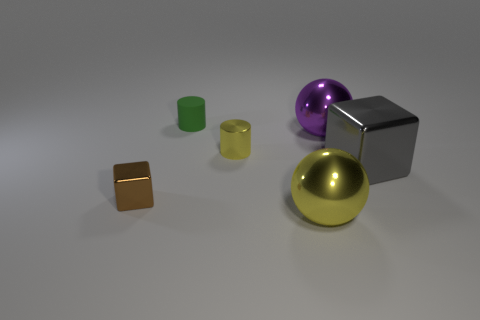There is a object that is the same color as the metal cylinder; what is its size?
Provide a short and direct response. Large. What material is the large thing that is in front of the tiny object that is in front of the large gray metallic block?
Your answer should be very brief. Metal. Are there any spheres that have the same color as the tiny metallic cylinder?
Your answer should be very brief. Yes. What color is the block that is the same size as the green cylinder?
Make the answer very short. Brown. What material is the ball in front of the yellow thing on the left side of the metallic ball that is in front of the purple ball?
Your answer should be very brief. Metal. Is the color of the matte cylinder the same as the block in front of the gray metallic thing?
Offer a terse response. No. How many objects are either shiny balls behind the tiny brown block or shiny cubes that are left of the small green rubber object?
Keep it short and to the point. 2. What is the shape of the big metal thing in front of the tiny metal thing in front of the tiny yellow metal cylinder?
Keep it short and to the point. Sphere. Are there any gray objects made of the same material as the purple thing?
Your answer should be very brief. Yes. What is the color of the other big metallic object that is the same shape as the purple object?
Offer a very short reply. Yellow. 